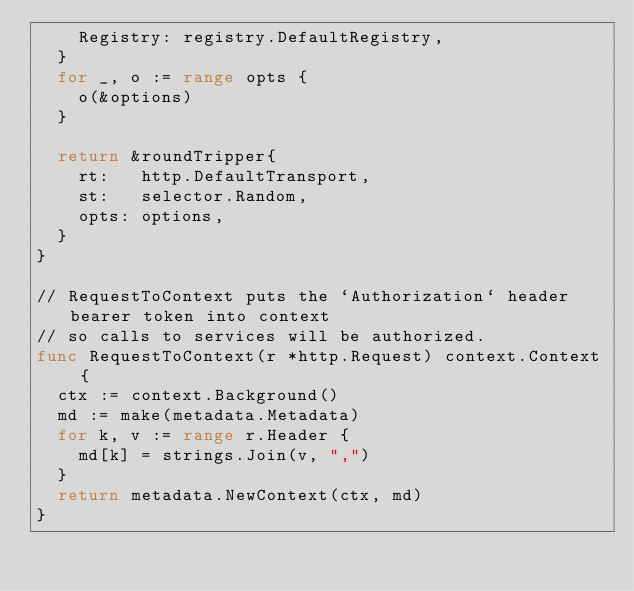Convert code to text. <code><loc_0><loc_0><loc_500><loc_500><_Go_>		Registry: registry.DefaultRegistry,
	}
	for _, o := range opts {
		o(&options)
	}

	return &roundTripper{
		rt:   http.DefaultTransport,
		st:   selector.Random,
		opts: options,
	}
}

// RequestToContext puts the `Authorization` header bearer token into context
// so calls to services will be authorized.
func RequestToContext(r *http.Request) context.Context {
	ctx := context.Background()
	md := make(metadata.Metadata)
	for k, v := range r.Header {
		md[k] = strings.Join(v, ",")
	}
	return metadata.NewContext(ctx, md)
}
</code> 